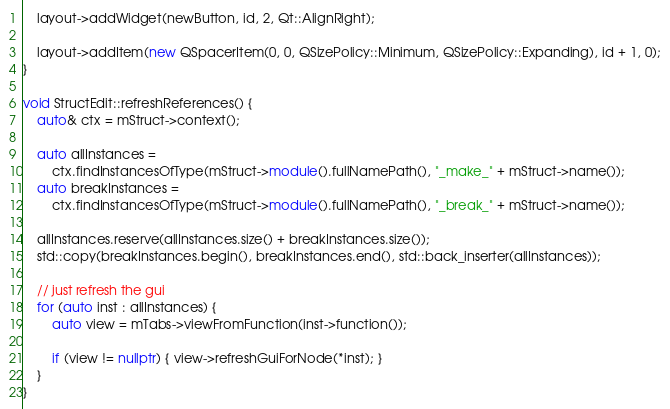<code> <loc_0><loc_0><loc_500><loc_500><_C++_>	layout->addWidget(newButton, id, 2, Qt::AlignRight);

	layout->addItem(new QSpacerItem(0, 0, QSizePolicy::Minimum, QSizePolicy::Expanding), id + 1, 0);
}

void StructEdit::refreshReferences() {
	auto& ctx = mStruct->context();

	auto allInstances =
	    ctx.findInstancesOfType(mStruct->module().fullNamePath(), "_make_" + mStruct->name());
	auto breakInstances =
	    ctx.findInstancesOfType(mStruct->module().fullNamePath(), "_break_" + mStruct->name());

	allInstances.reserve(allInstances.size() + breakInstances.size());
	std::copy(breakInstances.begin(), breakInstances.end(), std::back_inserter(allInstances));

	// just refresh the gui
	for (auto inst : allInstances) {
		auto view = mTabs->viewFromFunction(inst->function());

		if (view != nullptr) { view->refreshGuiForNode(*inst); }
	}
}
</code> 